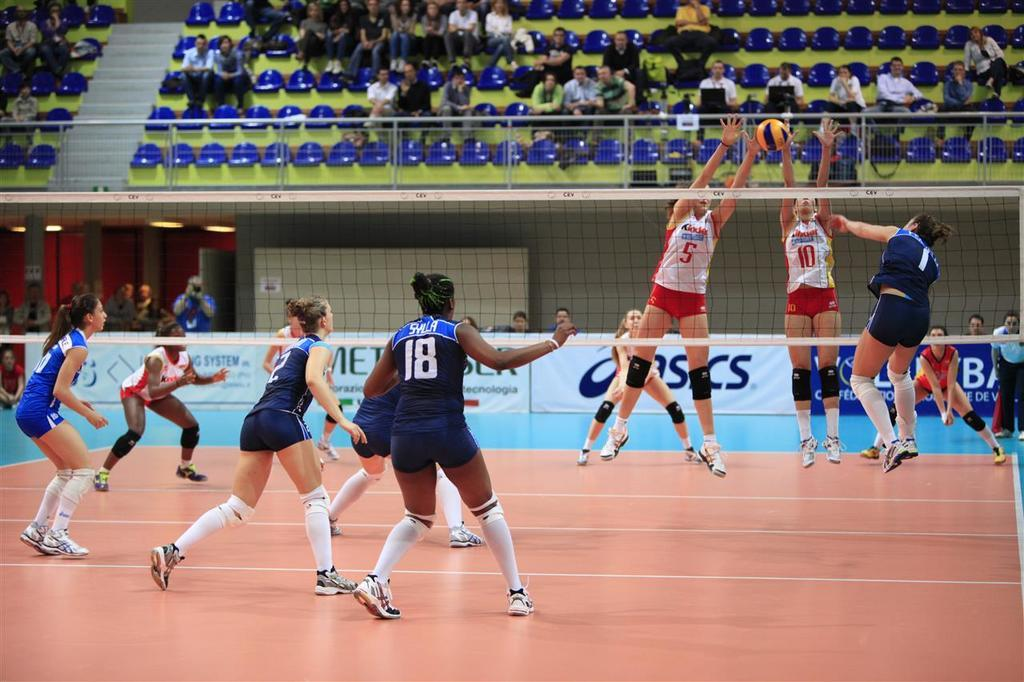What are the girls doing on the left side of the image? The girls are running on the left side of the image. What are the girls wearing on the left side of the image? The girls are wearing blue dresses on the left side of the image. What are the girls doing on the right side of the image? The girls are jumping on the right side of the image. What are the girls wearing on the right side of the image? The girls are wearing white tops on the right side of the image. Can you see a dog tying a knot in the image? No, there is no dog or knot present in the image. 